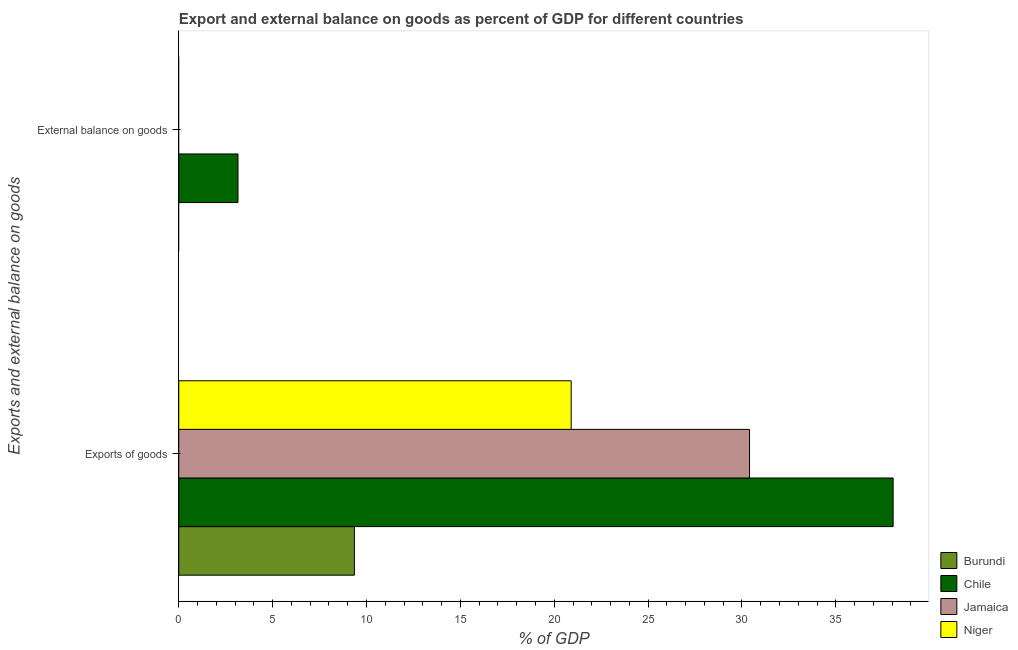What is the label of the 1st group of bars from the top?
Give a very brief answer. External balance on goods. What is the export of goods as percentage of gdp in Burundi?
Provide a succinct answer. 9.35. Across all countries, what is the maximum export of goods as percentage of gdp?
Offer a terse response. 38.05. Across all countries, what is the minimum export of goods as percentage of gdp?
Offer a very short reply. 9.35. In which country was the export of goods as percentage of gdp maximum?
Make the answer very short. Chile. What is the total export of goods as percentage of gdp in the graph?
Keep it short and to the point. 98.71. What is the difference between the export of goods as percentage of gdp in Niger and that in Burundi?
Offer a very short reply. 11.55. What is the difference between the external balance on goods as percentage of gdp in Burundi and the export of goods as percentage of gdp in Chile?
Keep it short and to the point. -38.05. What is the average external balance on goods as percentage of gdp per country?
Offer a very short reply. 0.79. What is the difference between the external balance on goods as percentage of gdp and export of goods as percentage of gdp in Chile?
Keep it short and to the point. -34.9. In how many countries, is the external balance on goods as percentage of gdp greater than 9 %?
Make the answer very short. 0. What is the ratio of the export of goods as percentage of gdp in Chile to that in Jamaica?
Your answer should be very brief. 1.25. Is the export of goods as percentage of gdp in Jamaica less than that in Niger?
Ensure brevity in your answer.  No. In how many countries, is the export of goods as percentage of gdp greater than the average export of goods as percentage of gdp taken over all countries?
Your answer should be compact. 2. Are all the bars in the graph horizontal?
Your response must be concise. Yes. How many countries are there in the graph?
Make the answer very short. 4. Does the graph contain grids?
Provide a succinct answer. No. Where does the legend appear in the graph?
Your answer should be very brief. Bottom right. What is the title of the graph?
Offer a terse response. Export and external balance on goods as percent of GDP for different countries. What is the label or title of the X-axis?
Provide a succinct answer. % of GDP. What is the label or title of the Y-axis?
Give a very brief answer. Exports and external balance on goods. What is the % of GDP of Burundi in Exports of goods?
Your answer should be compact. 9.35. What is the % of GDP in Chile in Exports of goods?
Your response must be concise. 38.05. What is the % of GDP of Jamaica in Exports of goods?
Your answer should be compact. 30.4. What is the % of GDP in Niger in Exports of goods?
Keep it short and to the point. 20.9. What is the % of GDP in Chile in External balance on goods?
Ensure brevity in your answer.  3.15. Across all Exports and external balance on goods, what is the maximum % of GDP of Burundi?
Your answer should be very brief. 9.35. Across all Exports and external balance on goods, what is the maximum % of GDP in Chile?
Ensure brevity in your answer.  38.05. Across all Exports and external balance on goods, what is the maximum % of GDP of Jamaica?
Ensure brevity in your answer.  30.4. Across all Exports and external balance on goods, what is the maximum % of GDP of Niger?
Keep it short and to the point. 20.9. Across all Exports and external balance on goods, what is the minimum % of GDP in Chile?
Keep it short and to the point. 3.15. Across all Exports and external balance on goods, what is the minimum % of GDP in Jamaica?
Keep it short and to the point. 0. Across all Exports and external balance on goods, what is the minimum % of GDP in Niger?
Keep it short and to the point. 0. What is the total % of GDP of Burundi in the graph?
Ensure brevity in your answer.  9.35. What is the total % of GDP in Chile in the graph?
Give a very brief answer. 41.2. What is the total % of GDP in Jamaica in the graph?
Your answer should be very brief. 30.4. What is the total % of GDP of Niger in the graph?
Your answer should be compact. 20.9. What is the difference between the % of GDP of Chile in Exports of goods and that in External balance on goods?
Make the answer very short. 34.9. What is the difference between the % of GDP of Burundi in Exports of goods and the % of GDP of Chile in External balance on goods?
Make the answer very short. 6.2. What is the average % of GDP of Burundi per Exports and external balance on goods?
Offer a very short reply. 4.68. What is the average % of GDP of Chile per Exports and external balance on goods?
Offer a terse response. 20.6. What is the average % of GDP of Jamaica per Exports and external balance on goods?
Keep it short and to the point. 15.2. What is the average % of GDP in Niger per Exports and external balance on goods?
Offer a very short reply. 10.45. What is the difference between the % of GDP of Burundi and % of GDP of Chile in Exports of goods?
Your answer should be compact. -28.7. What is the difference between the % of GDP of Burundi and % of GDP of Jamaica in Exports of goods?
Provide a succinct answer. -21.05. What is the difference between the % of GDP of Burundi and % of GDP of Niger in Exports of goods?
Provide a short and direct response. -11.55. What is the difference between the % of GDP in Chile and % of GDP in Jamaica in Exports of goods?
Your answer should be very brief. 7.65. What is the difference between the % of GDP of Chile and % of GDP of Niger in Exports of goods?
Provide a succinct answer. 17.15. What is the difference between the % of GDP of Jamaica and % of GDP of Niger in Exports of goods?
Your response must be concise. 9.5. What is the ratio of the % of GDP of Chile in Exports of goods to that in External balance on goods?
Your answer should be very brief. 12.06. What is the difference between the highest and the second highest % of GDP in Chile?
Your response must be concise. 34.9. What is the difference between the highest and the lowest % of GDP in Burundi?
Keep it short and to the point. 9.35. What is the difference between the highest and the lowest % of GDP in Chile?
Keep it short and to the point. 34.9. What is the difference between the highest and the lowest % of GDP of Jamaica?
Offer a very short reply. 30.4. What is the difference between the highest and the lowest % of GDP in Niger?
Make the answer very short. 20.9. 